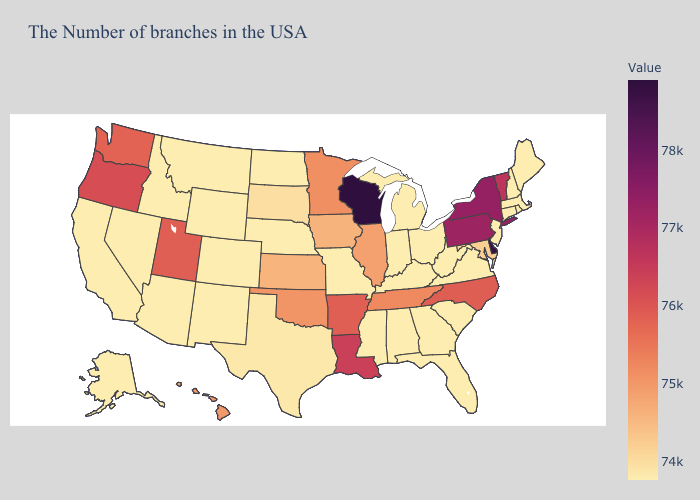Does South Dakota have the highest value in the USA?
Answer briefly. No. Does Wisconsin have the highest value in the USA?
Keep it brief. Yes. Does Wyoming have the highest value in the West?
Quick response, please. No. Among the states that border Virginia , which have the highest value?
Give a very brief answer. North Carolina. Which states have the highest value in the USA?
Write a very short answer. Wisconsin. 